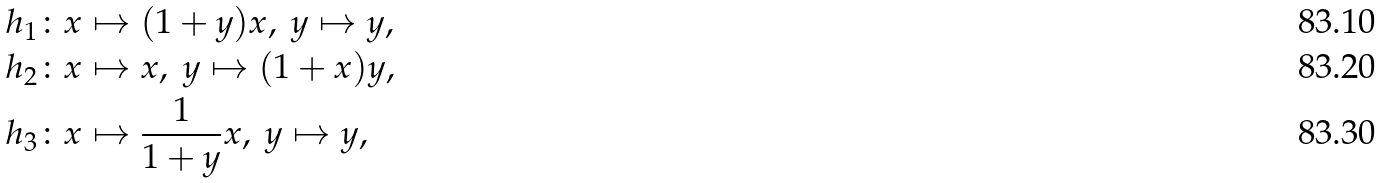Convert formula to latex. <formula><loc_0><loc_0><loc_500><loc_500>h _ { 1 } & \colon x \mapsto ( 1 + y ) x , \ y \mapsto y , \\ h _ { 2 } & \colon x \mapsto x , \ y \mapsto ( 1 + x ) y , \\ h _ { 3 } & \colon x \mapsto \frac { 1 } { 1 + y } x , \ y \mapsto y ,</formula> 